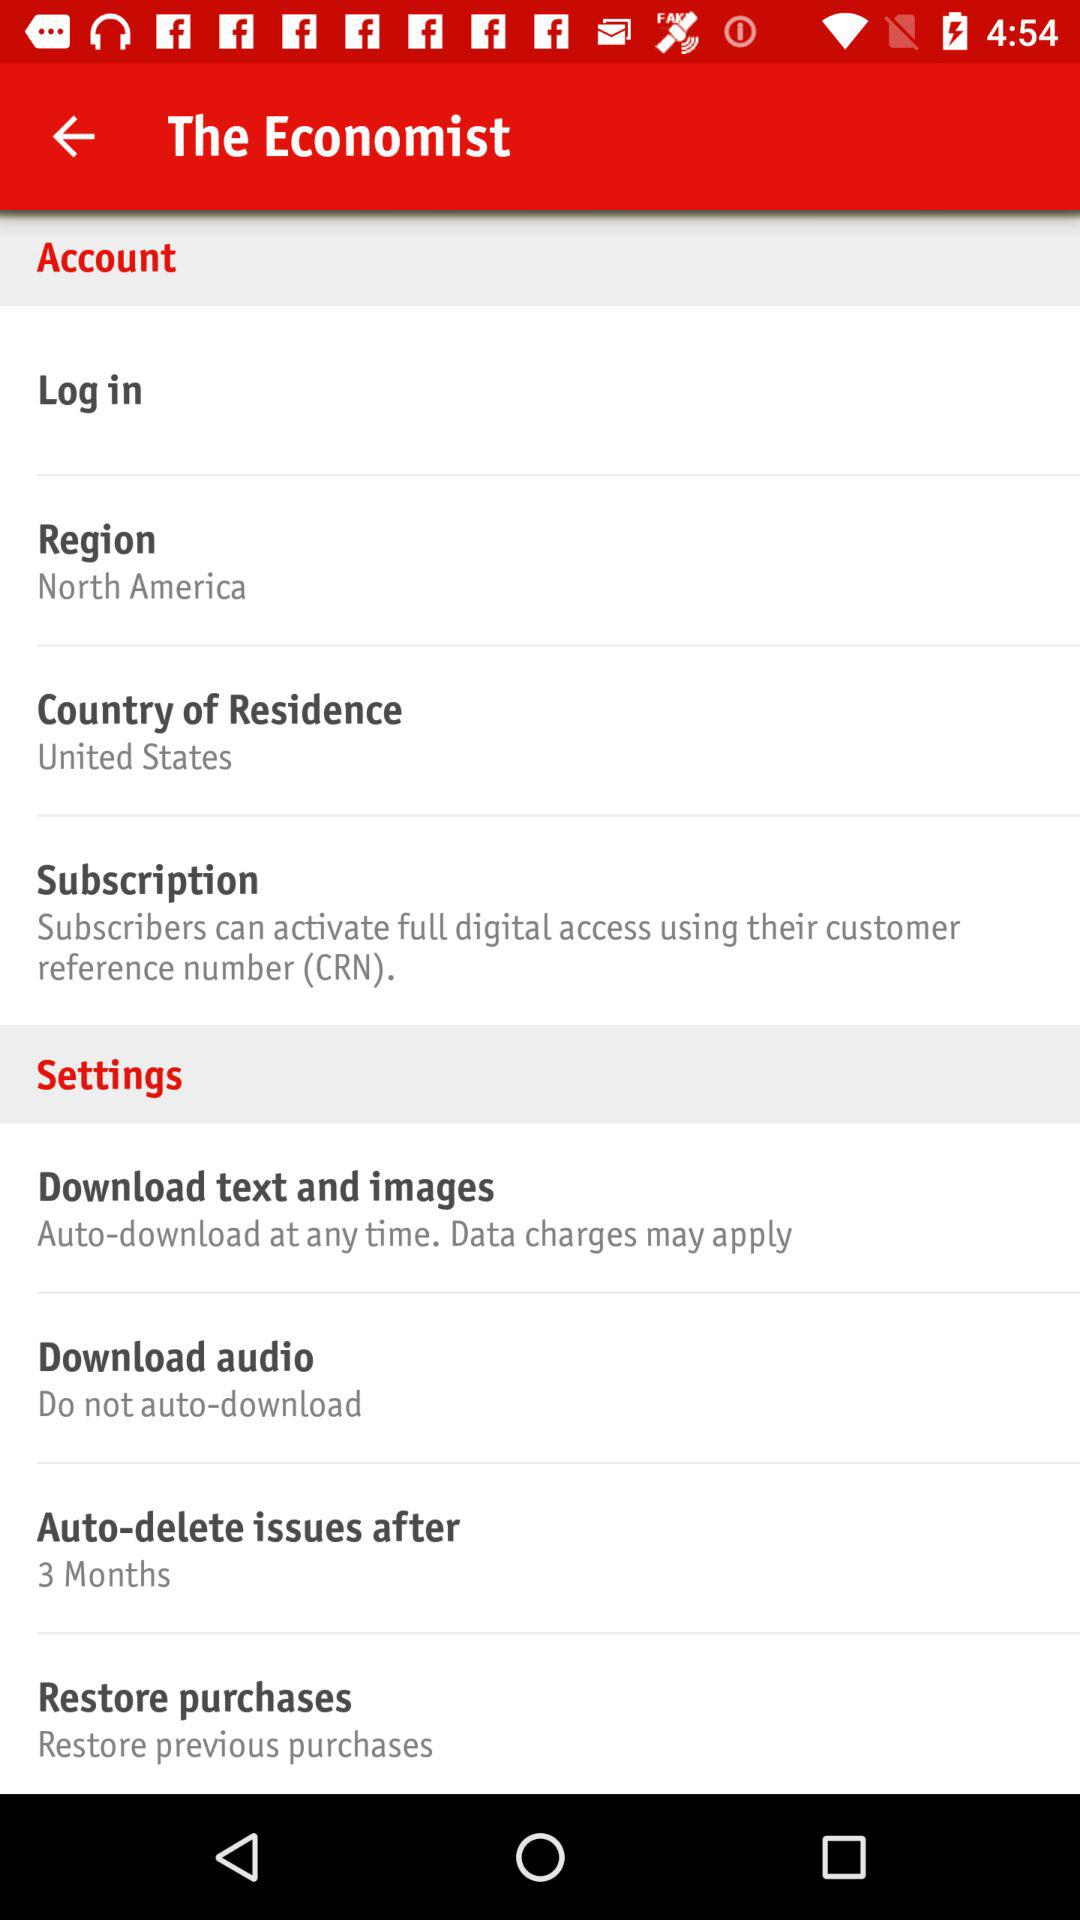What "Country of Residence" is selected? The selected "Country of Residence" is the United States. 